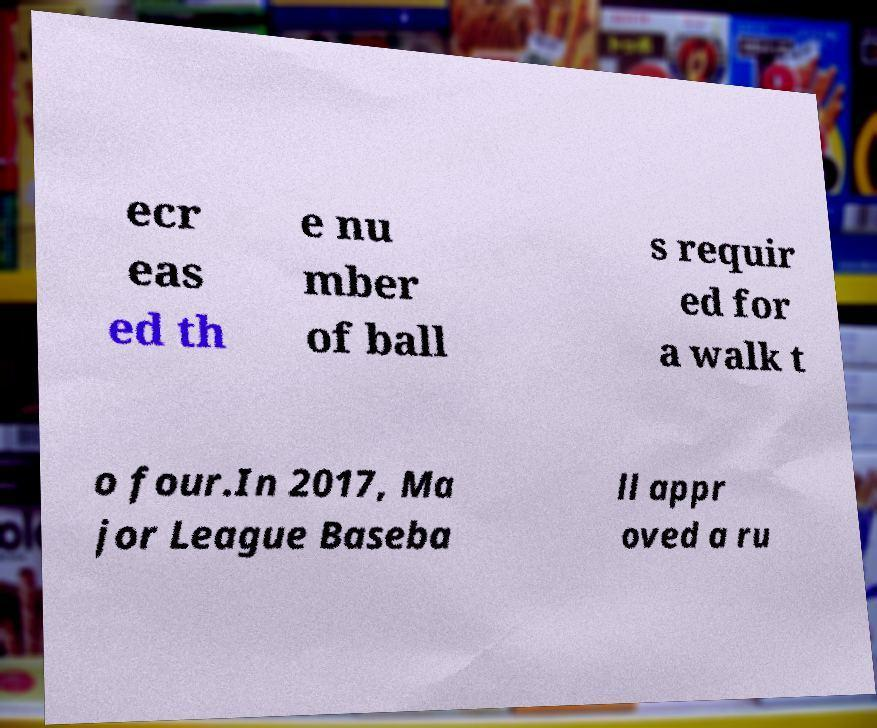I need the written content from this picture converted into text. Can you do that? ecr eas ed th e nu mber of ball s requir ed for a walk t o four.In 2017, Ma jor League Baseba ll appr oved a ru 